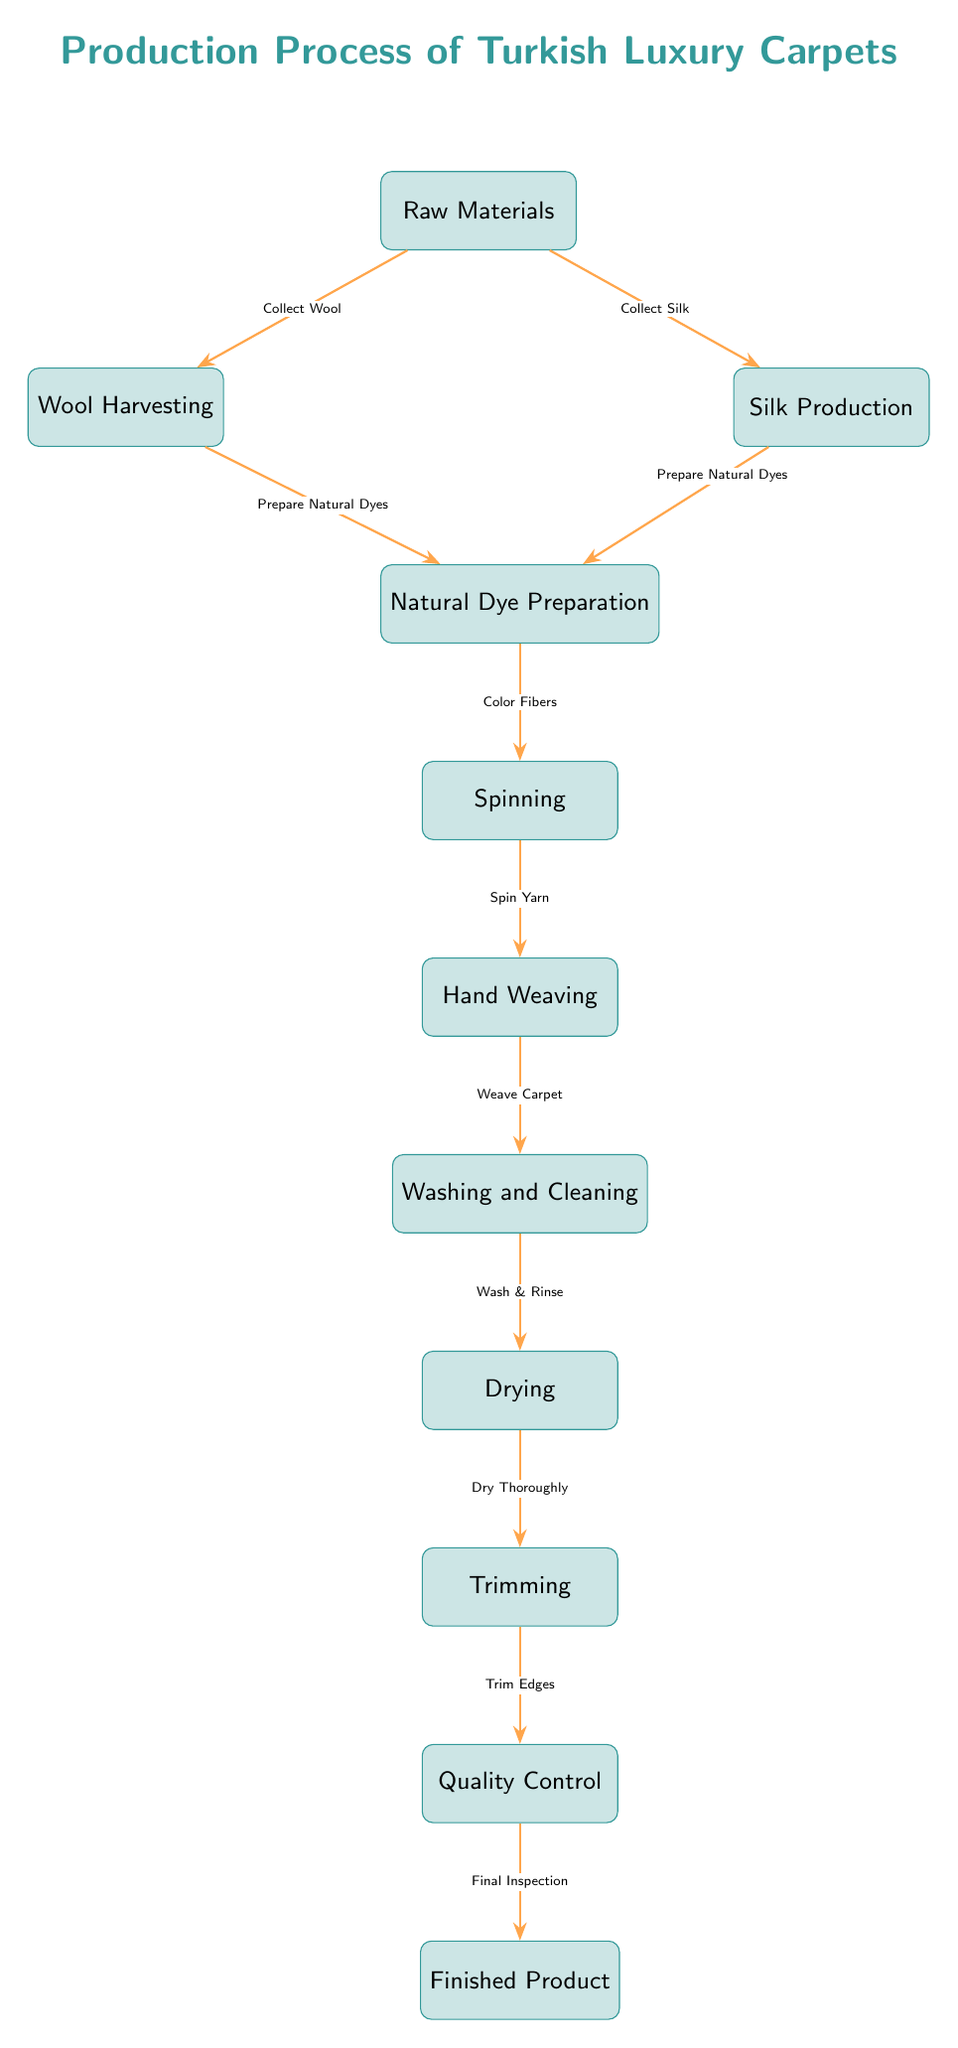What is the first step in the production process? The diagram indicates that the first step is "Raw Materials." It is the top node in the flowchart, signifying the starting point of the production process.
Answer: Raw Materials How many main steps are there in the production process? Counting the boxes in the diagram shows there are 10 main steps, from "Raw Materials" down to "Finished Product."
Answer: 10 What action follows "Weave Carpet"? The diagram clearly shows that the action that follows "Weave Carpet" is "Washing and Cleaning," as indicated by the direct arrow leading down to that node.
Answer: Washing and Cleaning Which step involves preparing natural dyes? The diagram shows two contributing steps that prepare natural dyes: "Wool Harvesting" and "Silk Production," both of which have arrows pointing towards "Natural Dye Preparation."
Answer: Wool Harvesting, Silk Production What is the final stage before producing the finished product? The diagram shows "Quality Control" as the final stage before "Finished Product." The arrow leads directly to the last node in the diagram.
Answer: Quality Control What indicates the transition from washing to drying? The transition is illustrated with an arrow labeled "Dry Thoroughly" leading from "Drying" to "Trimming," indicating the process flow.
Answer: Dry Thoroughly Which material preparation step directly follows "Wool Harvesting"? In the flowchart, "Wool Harvesting" directly leads to "Natural Dye Preparation," showing this as the next step in the process.
Answer: Natural Dye Preparation How is silk prepared in the production process? The diagram indicates that silk is prepared through the "Silk Production" step, which is connected to the "Natural Dye Preparation" step that follows.
Answer: Silk Production What does the quality control phase involve? The "Quality Control" phase is explicitly denoted as involving "Final Inspection," which is documented in the arrow leading toward the "Finished Product."
Answer: Final Inspection 